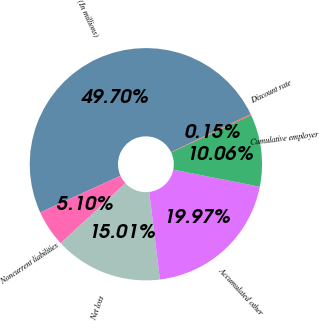Convert chart. <chart><loc_0><loc_0><loc_500><loc_500><pie_chart><fcel>(In millions)<fcel>Noncurrent liabilities<fcel>Net loss<fcel>Accumulated other<fcel>Cumulative employer<fcel>Discount rate<nl><fcel>49.7%<fcel>5.1%<fcel>15.01%<fcel>19.97%<fcel>10.06%<fcel>0.15%<nl></chart> 